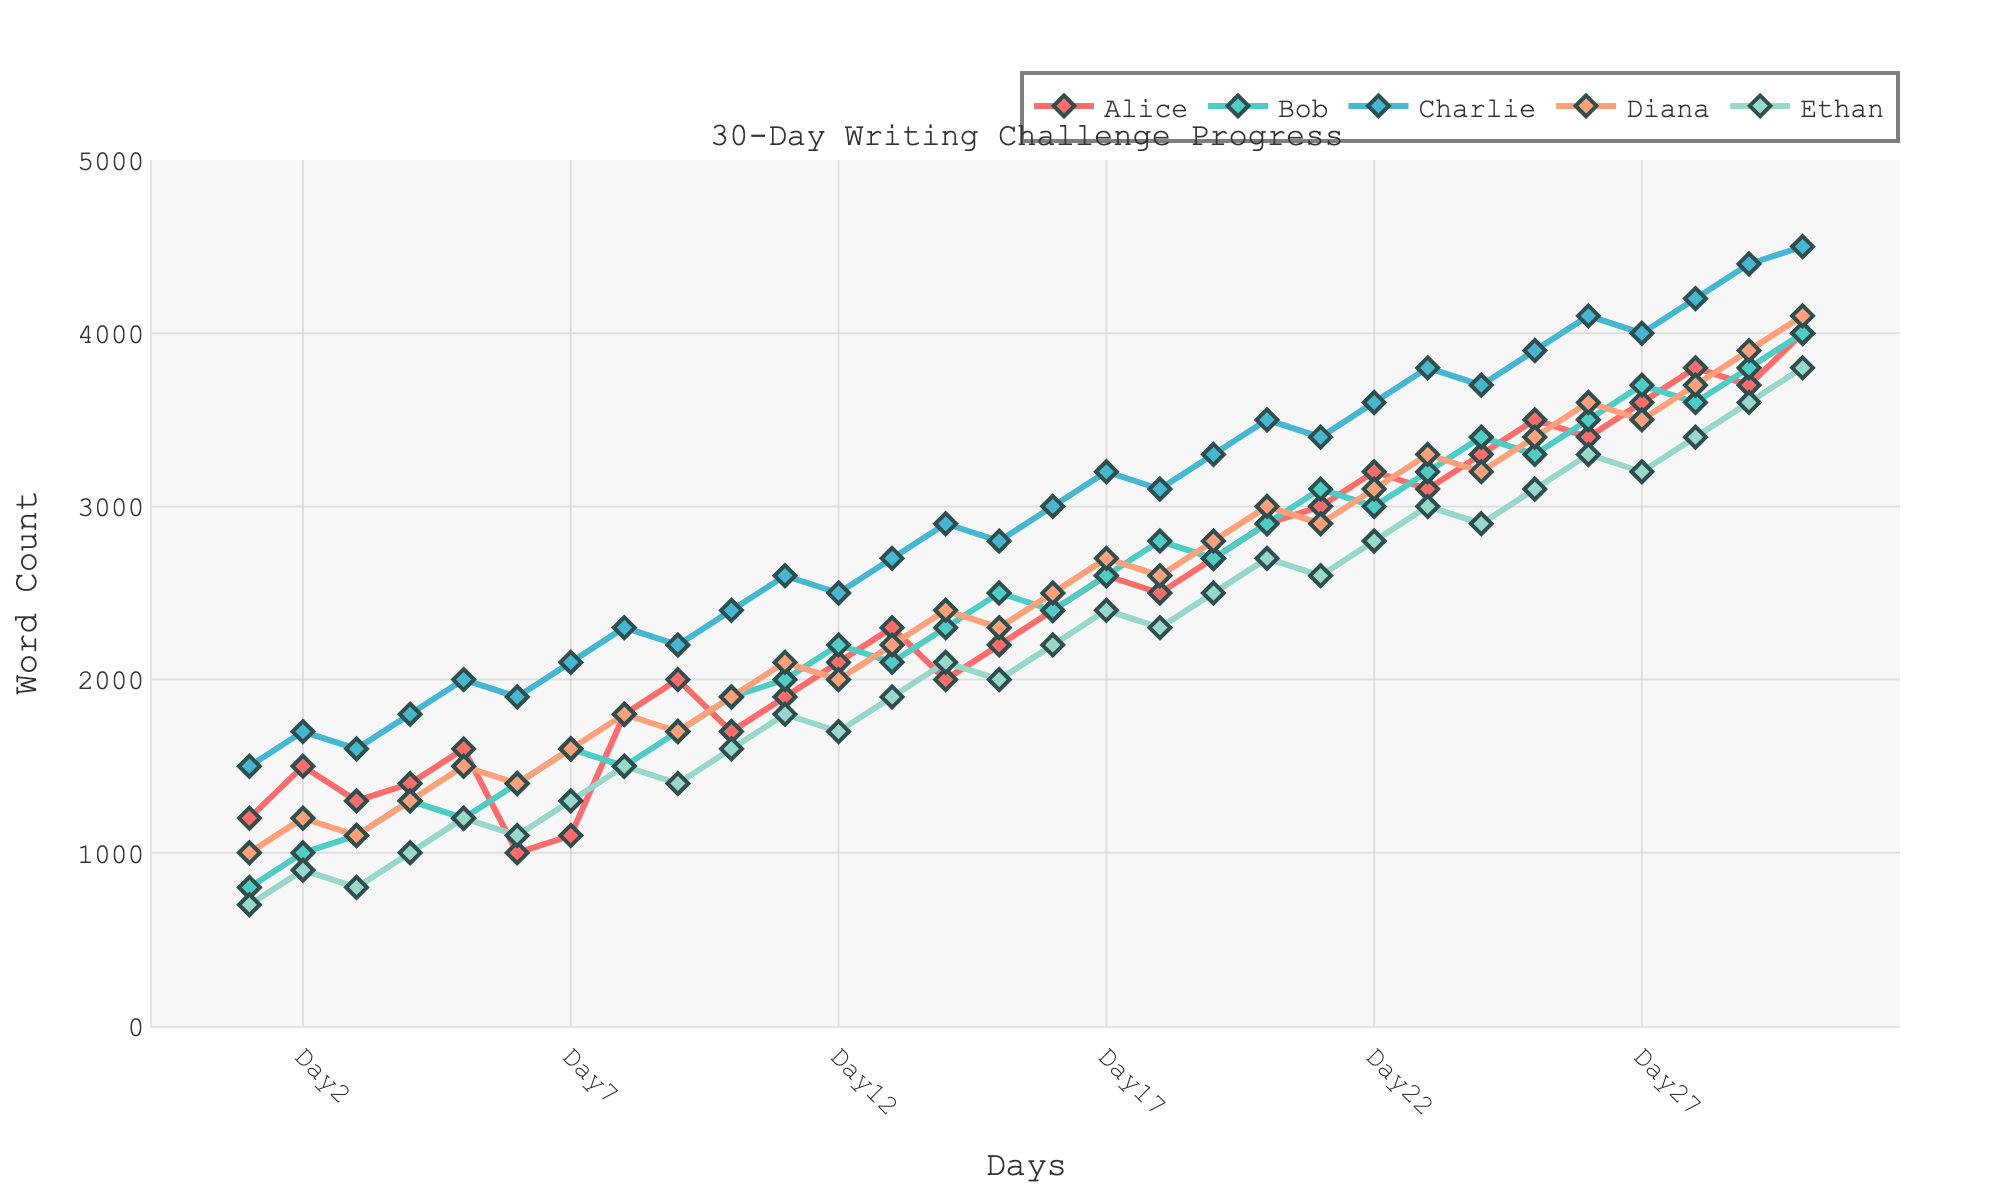Which writer had the highest word count on Day 30? On Day 30, observe the word counts for all writers; Charlie has the highest word count.
Answer: Charlie Which two writers had the same word count on any given day? By examining the lines for all writers, we can see that Bob and Ethan had the same word count (4000) on Day 30.
Answer: Bob and Ethan What is the total word count for Alice over the first 5 days? Add Alice's word counts from Day 1 to Day 5: 1200 + 1500 + 1300 + 1400 + 1600 = 7000.
Answer: 7000 Who had the lowest word count on Day 12? On Day 12, compare the word counts for each writer; Ethan had the lowest with 1700 words.
Answer: Ethan Which writer showed the most consistent increase in their word count over the 30 days? By observing the slopes of the lines, Charlie appears to show the most consistent increase in word count.
Answer: Charlie How many days did it take for Diana to reach a word count of 3000? Follow Diana's line and see that she reached 3000 words on Day 20.
Answer: 20 days Who wrote more words than Bob on Day 18? Compare the word counts on Day 18; Alice, Charlie, and Diana wrote more words than Bob.
Answer: Alice, Charlie, and Diana On which day did Ethan surpass 3500 words? Track Ethan's progress and observe that he surpassed 3500 words on Day 28.
Answer: Day 28 What is the difference in word count between Charlie and Ethan on Day 10? Subtract Ethan's word count from Charlie's word count on Day 10: 1900 - 1600 = 300 words.
Answer: 300 words What is the average daily word count for Diana over the entire 30-day period? Sum Diana's word counts and divide by 30. The sum is 91000, and dividing by 30 gives 3033.33.
Answer: 3033.33 words 